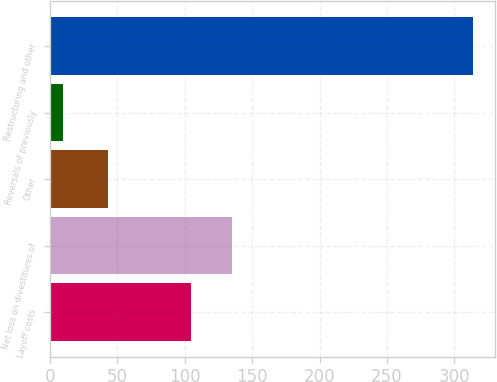Convert chart to OTSL. <chart><loc_0><loc_0><loc_500><loc_500><bar_chart><fcel>Layoff costs<fcel>Net loss on divestitures of<fcel>Other<fcel>Reversals of previously<fcel>Restructuring and other<nl><fcel>105<fcel>135.4<fcel>43<fcel>10<fcel>314<nl></chart> 